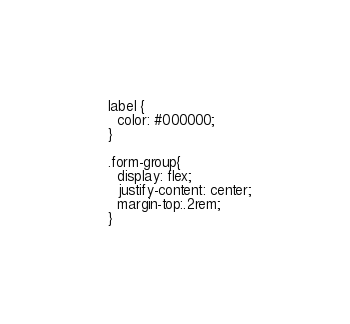Convert code to text. <code><loc_0><loc_0><loc_500><loc_500><_CSS_>  label {
    color: #000000;
  }
  
  .form-group{
    display: flex;
    justify-content: center;
    margin-top:.2rem;
  }</code> 